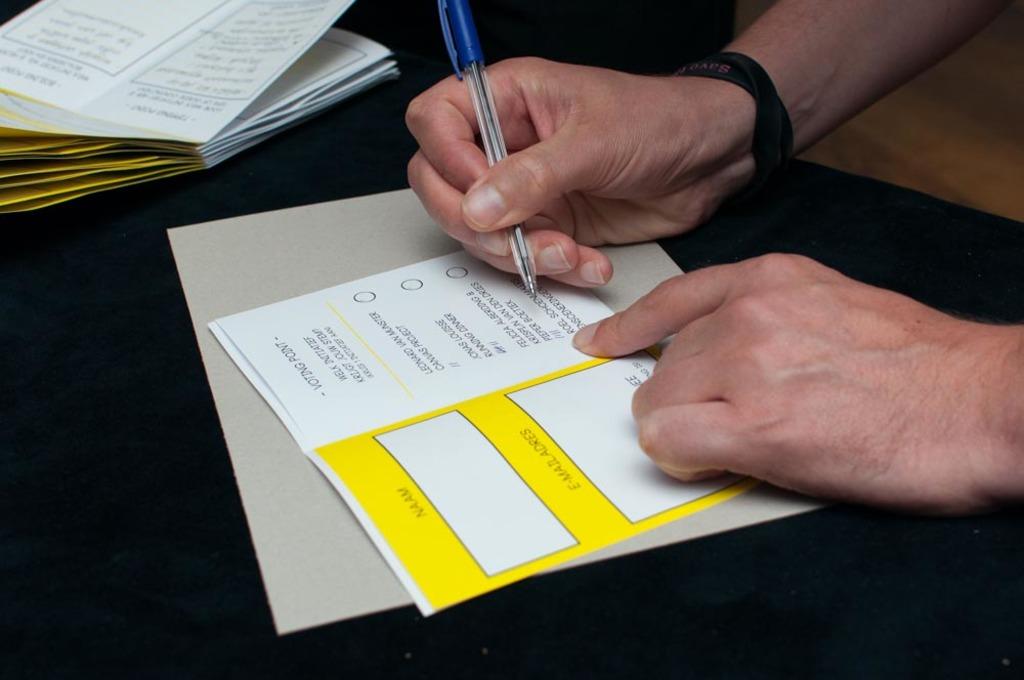What goes in the first white box?
Your answer should be compact. Name. What goes in the second white box?
Ensure brevity in your answer.  Email address. 